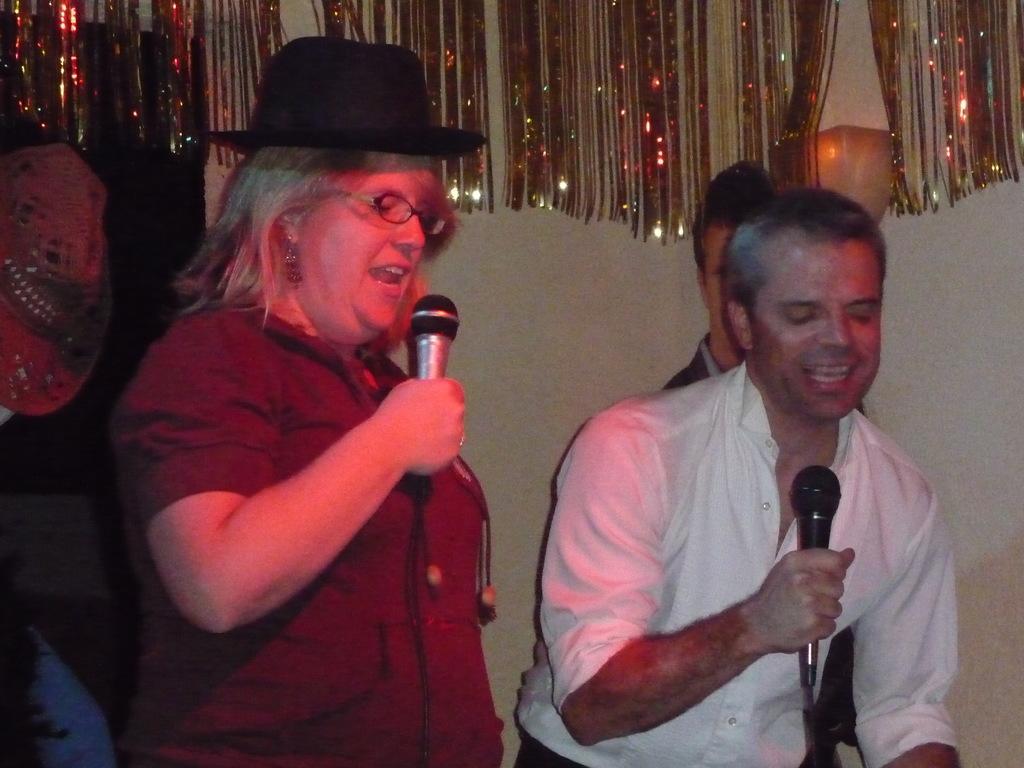In one or two sentences, can you explain what this image depicts? In this picture there is a woman singing in an microphone and there is another man who is also holding a microphone and singing 